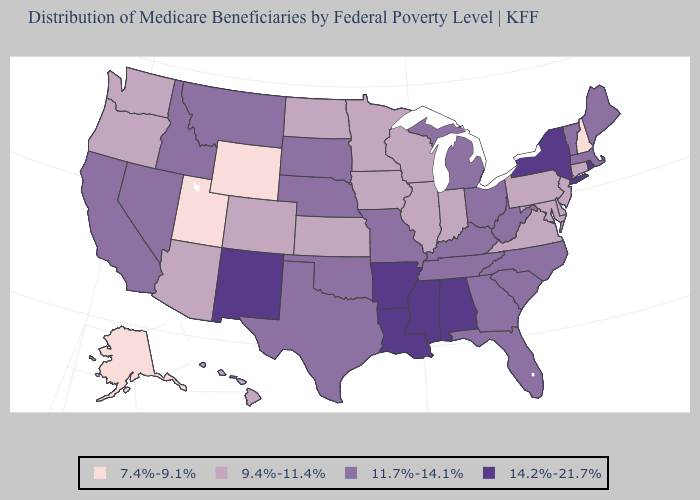Among the states that border New Mexico , does Utah have the lowest value?
Write a very short answer. Yes. Does Rhode Island have the same value as New Mexico?
Quick response, please. Yes. Which states have the highest value in the USA?
Keep it brief. Alabama, Arkansas, Louisiana, Mississippi, New Mexico, New York, Rhode Island. Name the states that have a value in the range 14.2%-21.7%?
Give a very brief answer. Alabama, Arkansas, Louisiana, Mississippi, New Mexico, New York, Rhode Island. Name the states that have a value in the range 9.4%-11.4%?
Concise answer only. Arizona, Colorado, Connecticut, Delaware, Hawaii, Illinois, Indiana, Iowa, Kansas, Maryland, Minnesota, New Jersey, North Dakota, Oregon, Pennsylvania, Virginia, Washington, Wisconsin. Does Oklahoma have the highest value in the USA?
Quick response, please. No. Does the first symbol in the legend represent the smallest category?
Write a very short answer. Yes. What is the value of Washington?
Keep it brief. 9.4%-11.4%. Name the states that have a value in the range 14.2%-21.7%?
Concise answer only. Alabama, Arkansas, Louisiana, Mississippi, New Mexico, New York, Rhode Island. Name the states that have a value in the range 11.7%-14.1%?
Be succinct. California, Florida, Georgia, Idaho, Kentucky, Maine, Massachusetts, Michigan, Missouri, Montana, Nebraska, Nevada, North Carolina, Ohio, Oklahoma, South Carolina, South Dakota, Tennessee, Texas, Vermont, West Virginia. What is the value of New Jersey?
Short answer required. 9.4%-11.4%. Name the states that have a value in the range 11.7%-14.1%?
Quick response, please. California, Florida, Georgia, Idaho, Kentucky, Maine, Massachusetts, Michigan, Missouri, Montana, Nebraska, Nevada, North Carolina, Ohio, Oklahoma, South Carolina, South Dakota, Tennessee, Texas, Vermont, West Virginia. Which states hav the highest value in the South?
Quick response, please. Alabama, Arkansas, Louisiana, Mississippi. What is the value of Montana?
Concise answer only. 11.7%-14.1%. 